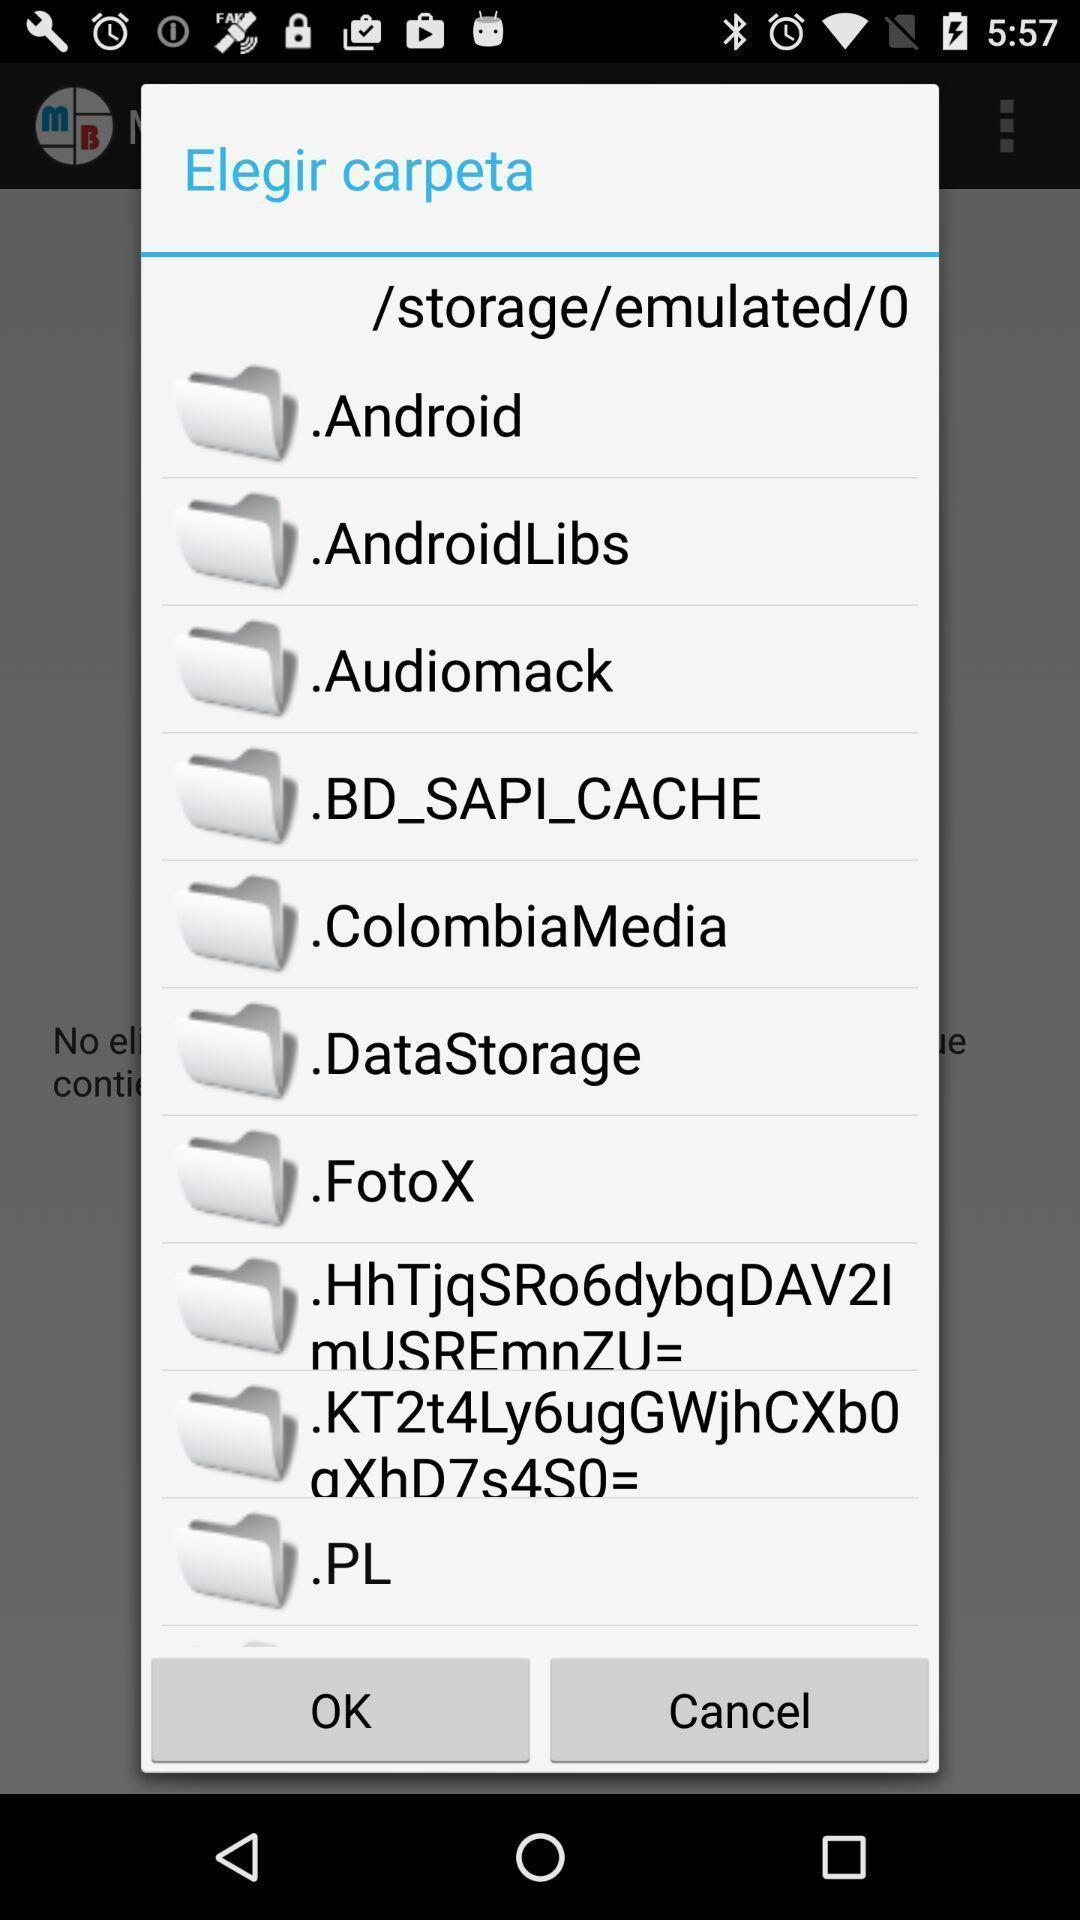Explain the elements present in this screenshot. Pop-up showing list of storage files. 